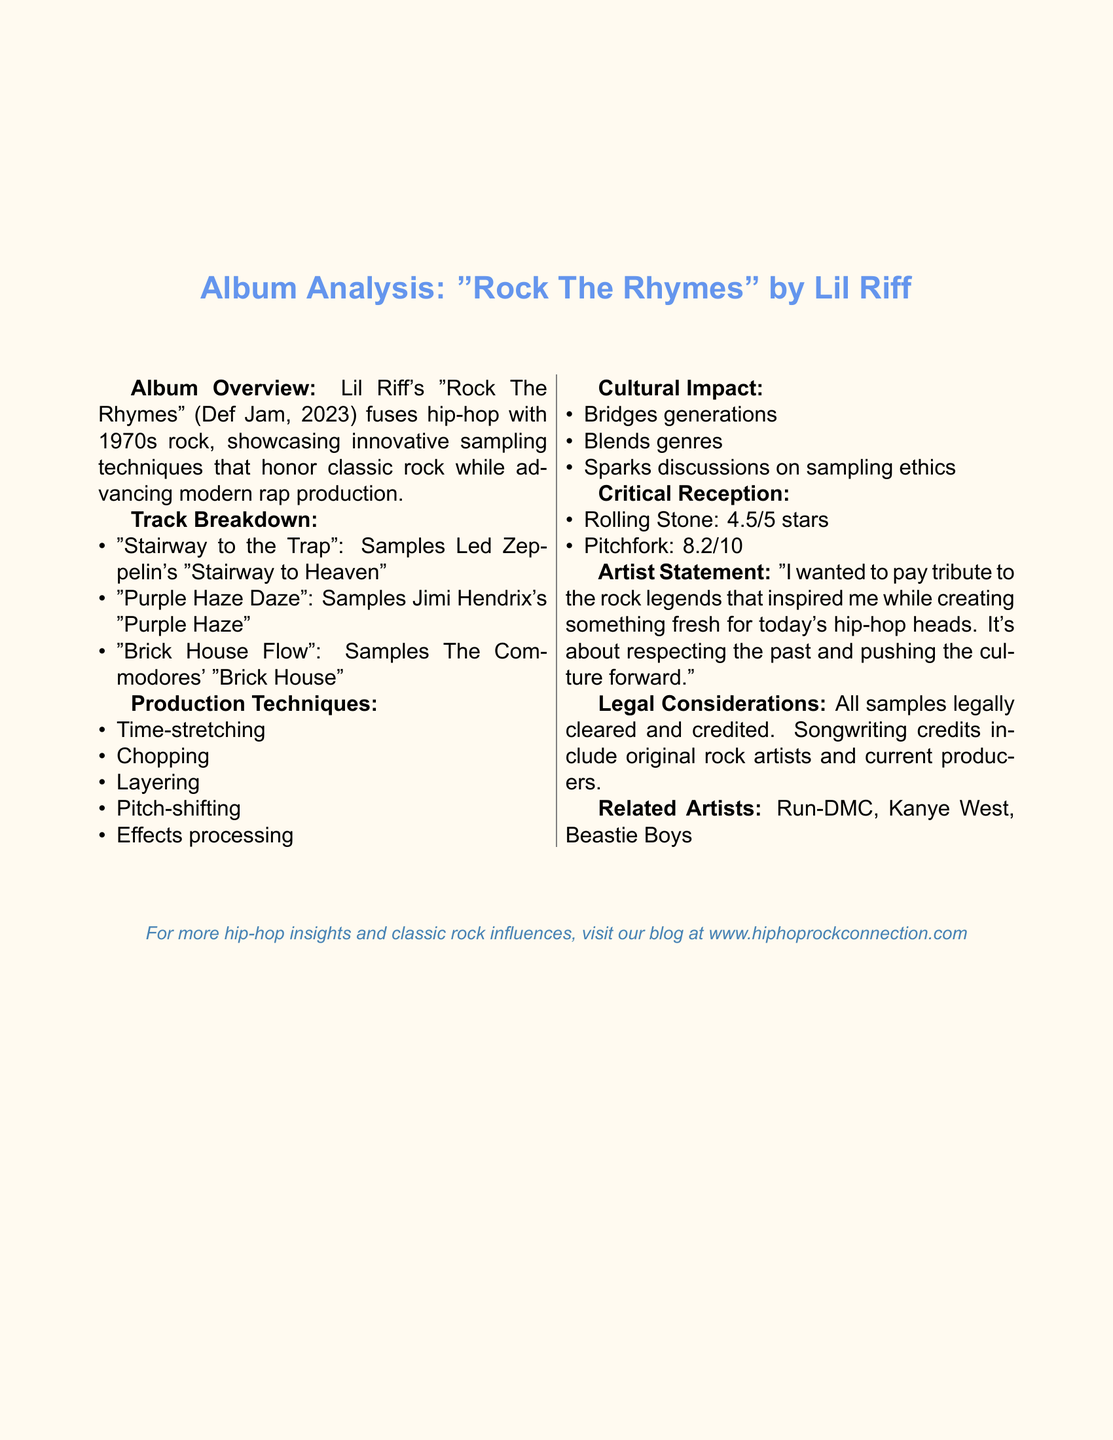What is the title of the album? The title of the album is given in the document as "Rock The Rhymes."
Answer: Rock The Rhymes Who is the artist of the album? The document specifies that the artist of the album is Lil Riff.
Answer: Lil Riff When was the album released? The release date of the album is stated in the document as May 15, 2023.
Answer: May 15, 2023 What rating did Rolling Stone give the album? The document includes a quote from Rolling Stone stating a rating of 4.5 out of 5 stars.
Answer: 4.5/5 stars Which song samples "Stairway to Heaven"? The track that samples "Stairway to Heaven" is mentioned as "Stairway to the Trap."
Answer: Stairway to the Trap What sampling technique is used in "Purple Haze Daze"? The document describes the sampling technique for "Purple Haze Daze" as pitch-shifted guitar riff, layered with synthesizer pads.
Answer: Pitch-shifted guitar riff, layered with synthesizer pads How does Lil Riff's album bridge generations? The document states that the album introduces classic rock to a younger audience through familiar hip-hop beats.
Answer: Introduces classic rock to a younger audience What is one of the cultural impacts of the album? The document mentions that the album challenges traditional genre boundaries and encourages cross-genre collaboration as a cultural impact.
Answer: Challenges traditional genre boundaries What legal consideration is mentioned regarding the samples? The document notes that all samples were legally cleared and credited in the album.
Answer: All samples legally cleared and credited 